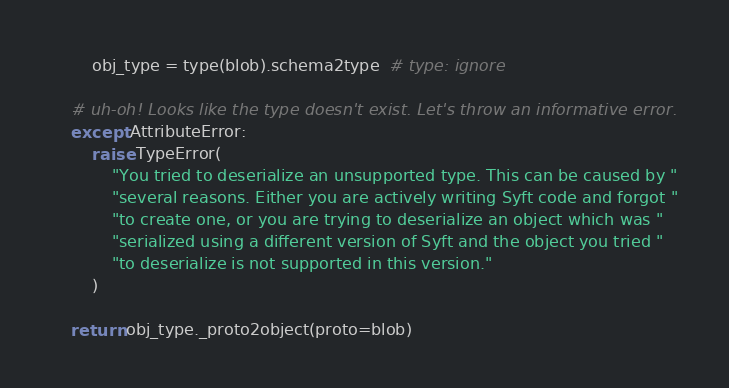<code> <loc_0><loc_0><loc_500><loc_500><_Python_>        obj_type = type(blob).schema2type  # type: ignore

    # uh-oh! Looks like the type doesn't exist. Let's throw an informative error.
    except AttributeError:
        raise TypeError(
            "You tried to deserialize an unsupported type. This can be caused by "
            "several reasons. Either you are actively writing Syft code and forgot "
            "to create one, or you are trying to deserialize an object which was "
            "serialized using a different version of Syft and the object you tried "
            "to deserialize is not supported in this version."
        )

    return obj_type._proto2object(proto=blob)
</code> 